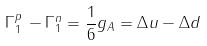<formula> <loc_0><loc_0><loc_500><loc_500>\Gamma _ { 1 } ^ { p } \, - \Gamma _ { 1 } ^ { n } = \frac { 1 } { 6 } g _ { A } = \Delta u - \Delta d</formula> 